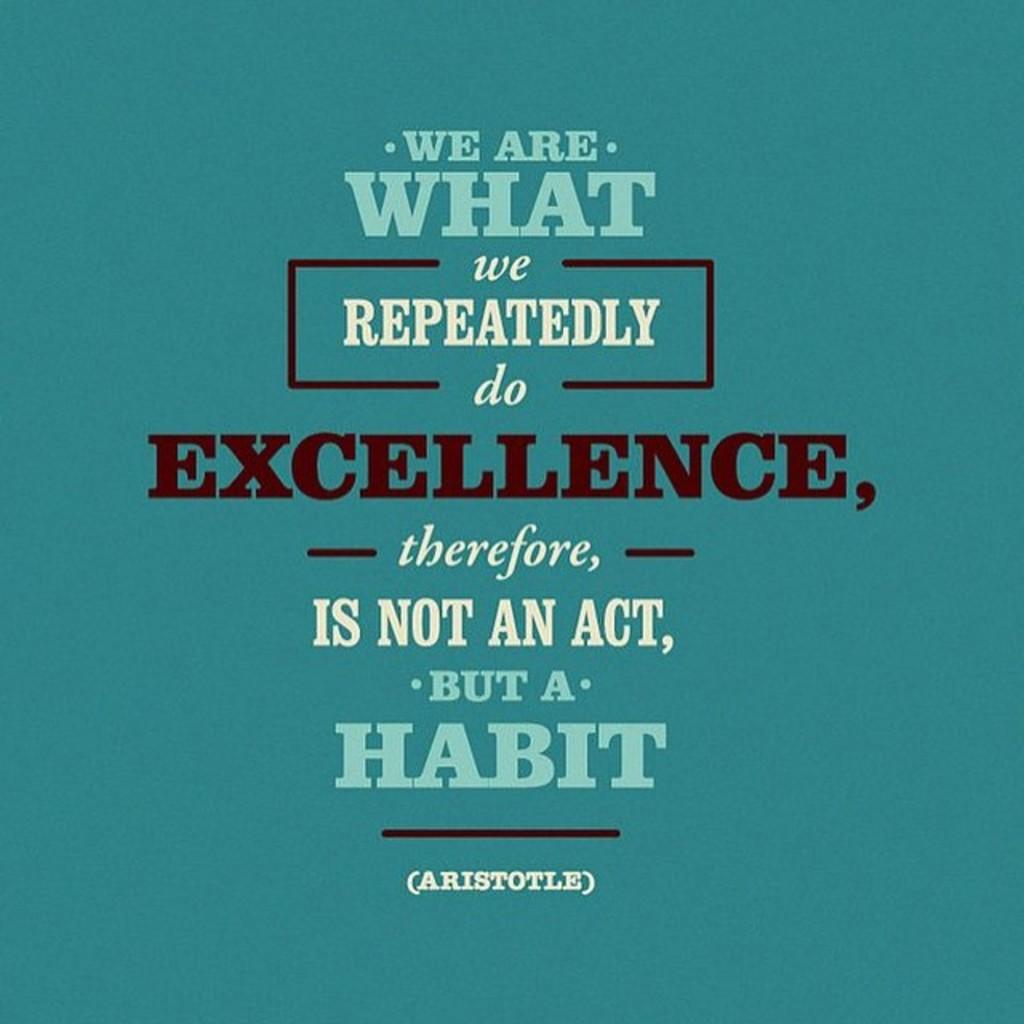Who said this quote?
Provide a short and direct response. Aristotle. What is the third word?
Offer a very short reply. What. 